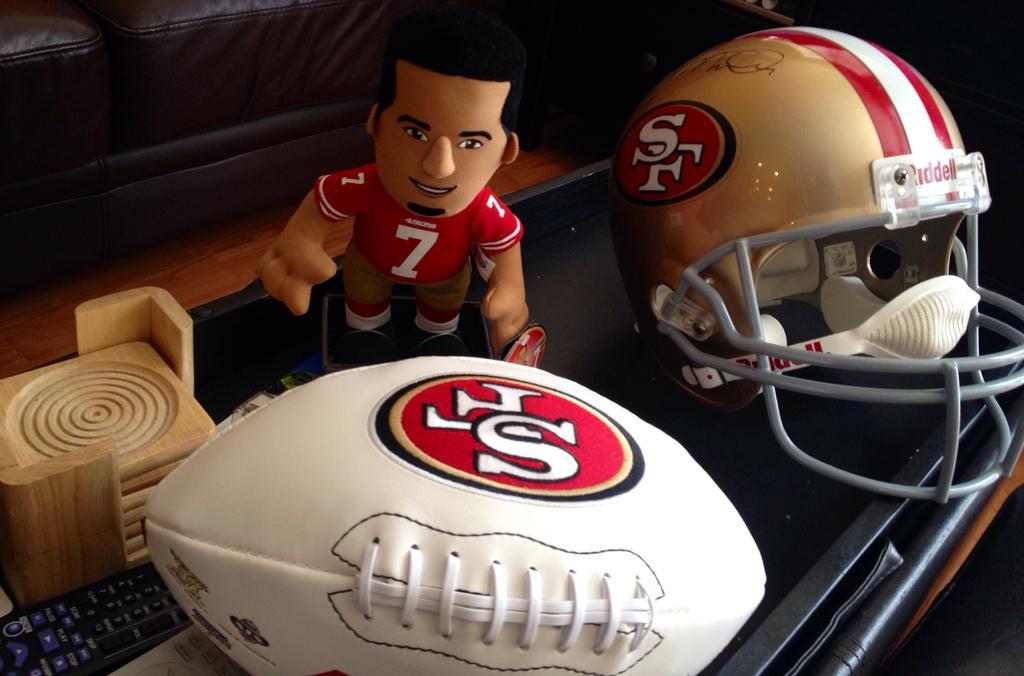Could you give a brief overview of what you see in this image? In this picture we can see a toy, helmet, ball, remote and a wooden object and these all are on a platform and in the background we can see some objects. 